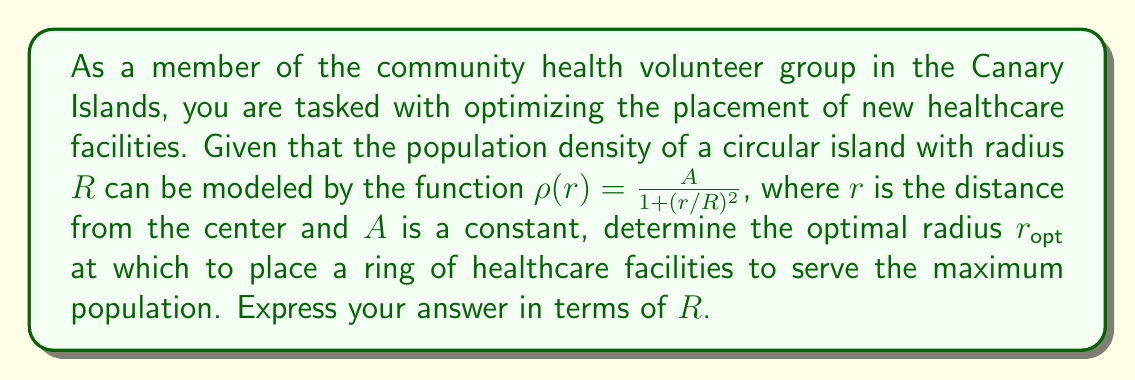Give your solution to this math problem. To solve this problem, we need to follow these steps:

1) The population served by a thin ring at radius $r$ is proportional to the product of the population density and the circumference of the ring. Let's call this function $P(r)$:

   $$P(r) \propto \rho(r) \cdot 2\pi r = \frac{2\pi A r}{1 + (r/R)^2}$$

2) To find the maximum of this function, we need to differentiate it with respect to $r$ and set it to zero:

   $$\frac{dP}{dr} = 2\pi A \cdot \frac{(1 + (r/R)^2) - 2r^2/R^2}{(1 + (r/R)^2)^2} = 0$$

3) Simplifying the numerator:

   $$1 + (r/R)^2 - 2(r/R)^2 = 1 - (r/R)^2 = 0$$

4) Solving this equation:

   $$1 - (r/R)^2 = 0$$
   $$(r/R)^2 = 1$$
   $$r = R$$

5) To confirm this is a maximum, we can check the second derivative is negative at this point (omitted for brevity).

Therefore, the optimal radius to place the healthcare facilities is equal to the radius of the island.
Answer: $r_{\text{opt}} = R$ 